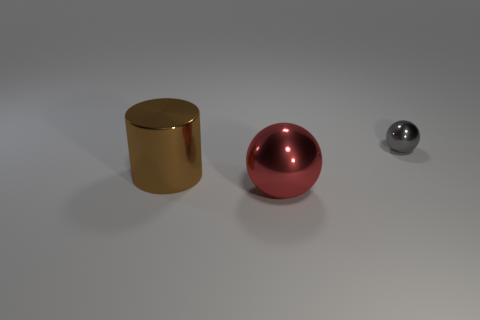Can you tell what time of day it is based on the lighting in the image? The lighting in the image does not provide clear indicators of the time of day since the environment is a neutral, gradient background without any discernible natural light sources such as a sun or a sky. The light appears artificial and diffuse, suggesting that the image could have been taken indoors or in a studio setting where the lighting is controlled. 